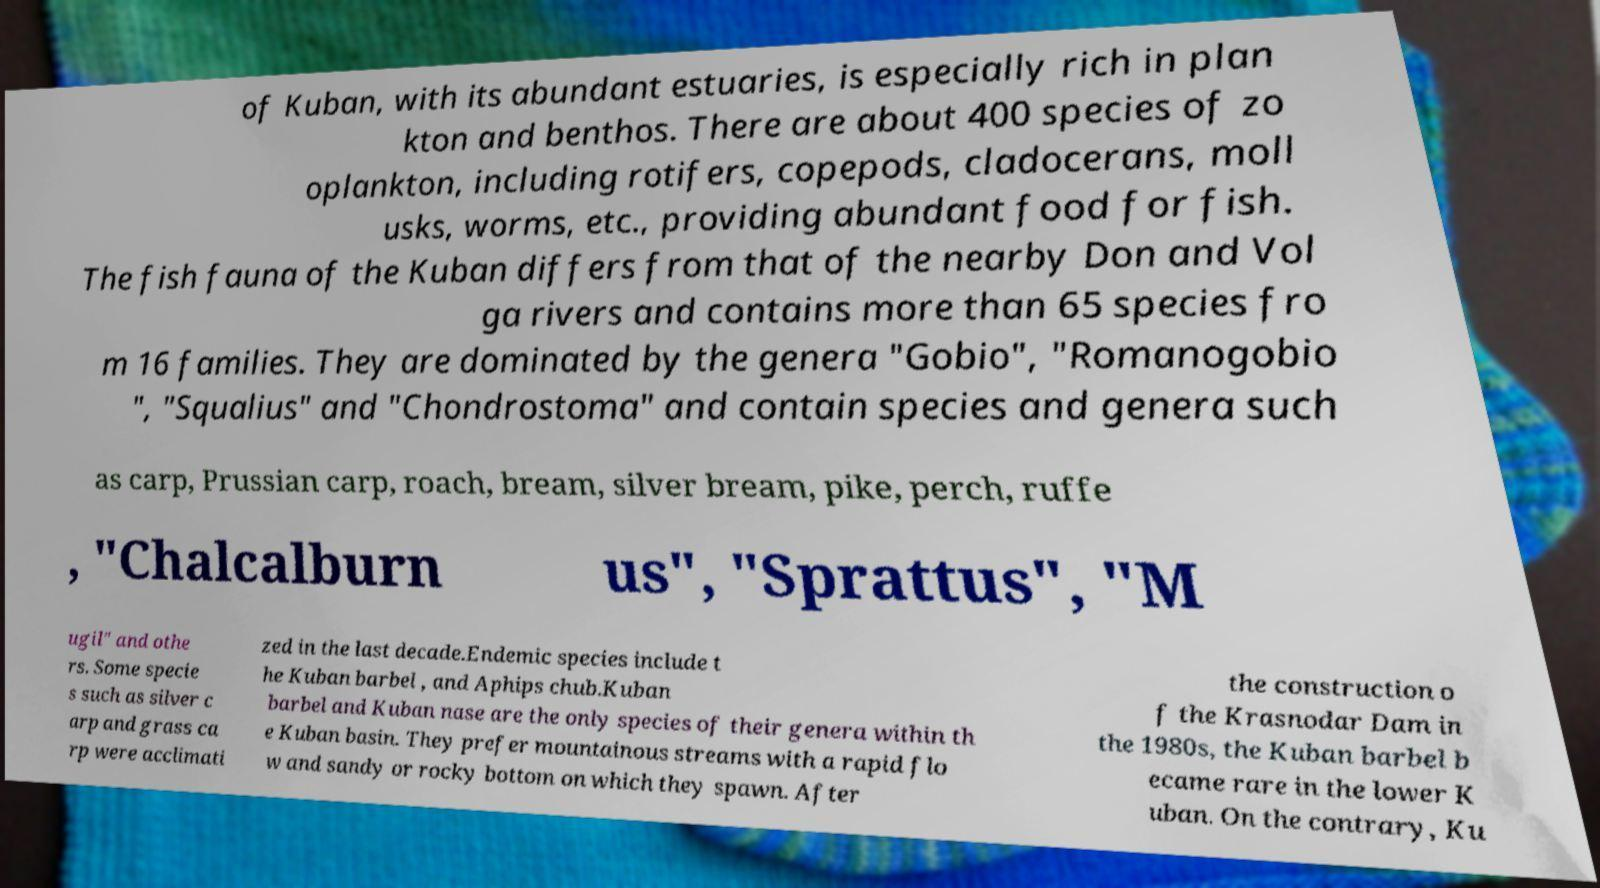Could you assist in decoding the text presented in this image and type it out clearly? of Kuban, with its abundant estuaries, is especially rich in plan kton and benthos. There are about 400 species of zo oplankton, including rotifers, copepods, cladocerans, moll usks, worms, etc., providing abundant food for fish. The fish fauna of the Kuban differs from that of the nearby Don and Vol ga rivers and contains more than 65 species fro m 16 families. They are dominated by the genera "Gobio", "Romanogobio ", "Squalius" and "Chondrostoma" and contain species and genera such as carp, Prussian carp, roach, bream, silver bream, pike, perch, ruffe , "Chalcalburn us", "Sprattus", "M ugil" and othe rs. Some specie s such as silver c arp and grass ca rp were acclimati zed in the last decade.Endemic species include t he Kuban barbel , and Aphips chub.Kuban barbel and Kuban nase are the only species of their genera within th e Kuban basin. They prefer mountainous streams with a rapid flo w and sandy or rocky bottom on which they spawn. After the construction o f the Krasnodar Dam in the 1980s, the Kuban barbel b ecame rare in the lower K uban. On the contrary, Ku 